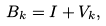Convert formula to latex. <formula><loc_0><loc_0><loc_500><loc_500>B _ { k } = I + V _ { k } ,</formula> 